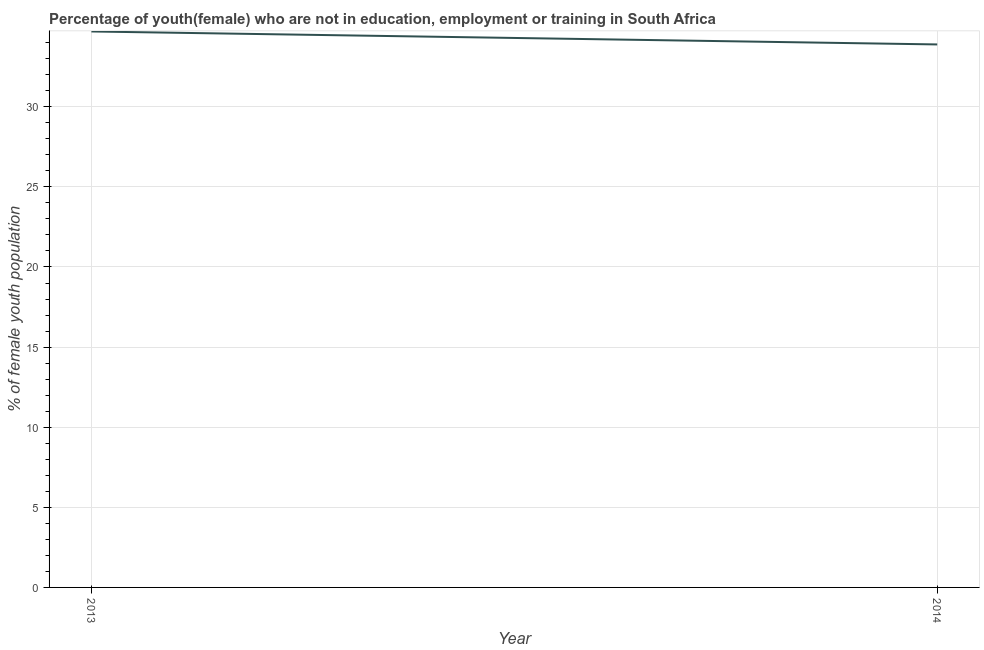What is the unemployed female youth population in 2014?
Provide a succinct answer. 33.89. Across all years, what is the maximum unemployed female youth population?
Make the answer very short. 34.7. Across all years, what is the minimum unemployed female youth population?
Make the answer very short. 33.89. In which year was the unemployed female youth population minimum?
Your response must be concise. 2014. What is the sum of the unemployed female youth population?
Provide a short and direct response. 68.59. What is the difference between the unemployed female youth population in 2013 and 2014?
Your response must be concise. 0.81. What is the average unemployed female youth population per year?
Offer a very short reply. 34.3. What is the median unemployed female youth population?
Your answer should be very brief. 34.3. In how many years, is the unemployed female youth population greater than 12 %?
Offer a very short reply. 2. What is the ratio of the unemployed female youth population in 2013 to that in 2014?
Make the answer very short. 1.02. Is the unemployed female youth population in 2013 less than that in 2014?
Your answer should be compact. No. In how many years, is the unemployed female youth population greater than the average unemployed female youth population taken over all years?
Provide a succinct answer. 1. Does the unemployed female youth population monotonically increase over the years?
Provide a short and direct response. No. How many lines are there?
Offer a very short reply. 1. What is the difference between two consecutive major ticks on the Y-axis?
Your answer should be very brief. 5. What is the title of the graph?
Offer a terse response. Percentage of youth(female) who are not in education, employment or training in South Africa. What is the label or title of the Y-axis?
Your response must be concise. % of female youth population. What is the % of female youth population of 2013?
Offer a terse response. 34.7. What is the % of female youth population of 2014?
Your answer should be very brief. 33.89. What is the difference between the % of female youth population in 2013 and 2014?
Provide a succinct answer. 0.81. What is the ratio of the % of female youth population in 2013 to that in 2014?
Keep it short and to the point. 1.02. 